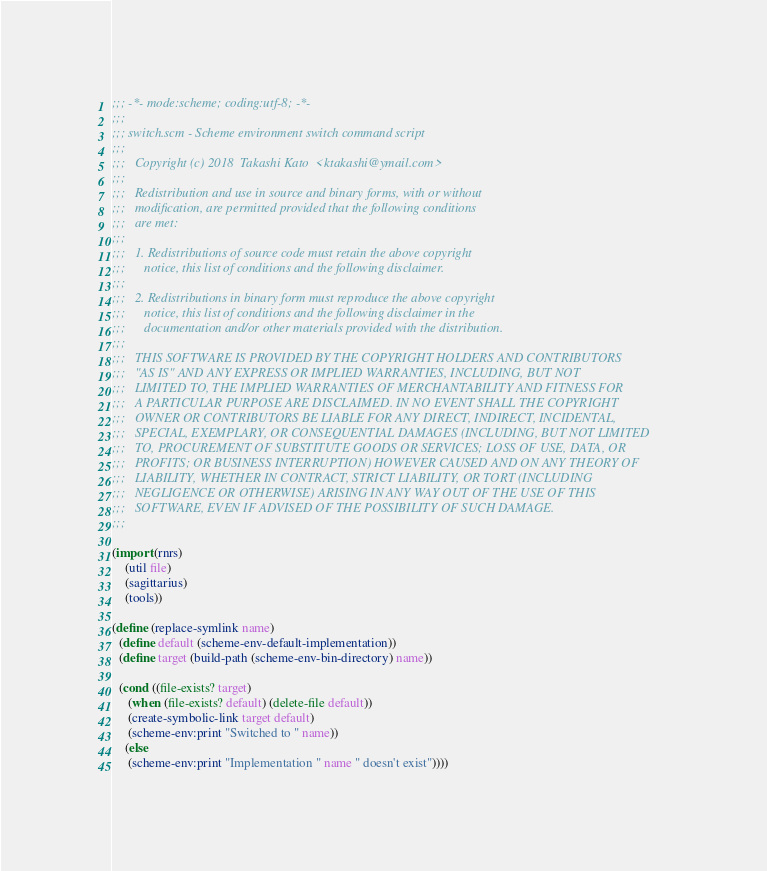<code> <loc_0><loc_0><loc_500><loc_500><_Scheme_>;;; -*- mode:scheme; coding:utf-8; -*-
;;;
;;; switch.scm - Scheme environment switch command script
;;;  
;;;   Copyright (c) 2018  Takashi Kato  <ktakashi@ymail.com>
;;;   
;;;   Redistribution and use in source and binary forms, with or without
;;;   modification, are permitted provided that the following conditions
;;;   are met:
;;;   
;;;   1. Redistributions of source code must retain the above copyright
;;;      notice, this list of conditions and the following disclaimer.
;;;  
;;;   2. Redistributions in binary form must reproduce the above copyright
;;;      notice, this list of conditions and the following disclaimer in the
;;;      documentation and/or other materials provided with the distribution.
;;;  
;;;   THIS SOFTWARE IS PROVIDED BY THE COPYRIGHT HOLDERS AND CONTRIBUTORS
;;;   "AS IS" AND ANY EXPRESS OR IMPLIED WARRANTIES, INCLUDING, BUT NOT
;;;   LIMITED TO, THE IMPLIED WARRANTIES OF MERCHANTABILITY AND FITNESS FOR
;;;   A PARTICULAR PURPOSE ARE DISCLAIMED. IN NO EVENT SHALL THE COPYRIGHT
;;;   OWNER OR CONTRIBUTORS BE LIABLE FOR ANY DIRECT, INDIRECT, INCIDENTAL,
;;;   SPECIAL, EXEMPLARY, OR CONSEQUENTIAL DAMAGES (INCLUDING, BUT NOT LIMITED
;;;   TO, PROCUREMENT OF SUBSTITUTE GOODS OR SERVICES; LOSS OF USE, DATA, OR
;;;   PROFITS; OR BUSINESS INTERRUPTION) HOWEVER CAUSED AND ON ANY THEORY OF
;;;   LIABILITY, WHETHER IN CONTRACT, STRICT LIABILITY, OR TORT (INCLUDING
;;;   NEGLIGENCE OR OTHERWISE) ARISING IN ANY WAY OUT OF THE USE OF THIS
;;;   SOFTWARE, EVEN IF ADVISED OF THE POSSIBILITY OF SUCH DAMAGE.
;;;  

(import (rnrs)
	(util file)
	(sagittarius)
	(tools))

(define (replace-symlink name)
  (define default (scheme-env-default-implementation))
  (define target (build-path (scheme-env-bin-directory) name))

  (cond ((file-exists? target)
	 (when (file-exists? default) (delete-file default))
	 (create-symbolic-link target default)
	 (scheme-env:print "Switched to " name))
	(else
	 (scheme-env:print "Implementation " name " doesn't exist"))))
</code> 